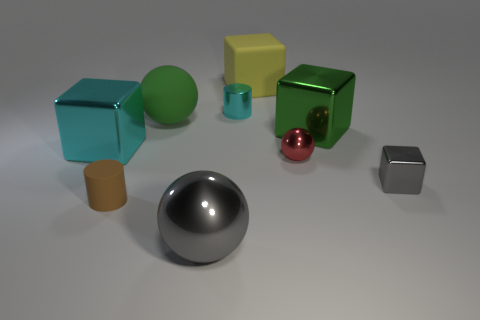What material is the big cyan thing that is the same shape as the tiny gray thing?
Ensure brevity in your answer.  Metal. There is a metal cube that is left of the large yellow object; is its color the same as the tiny metal cylinder?
Your answer should be very brief. Yes. What number of large yellow things are there?
Ensure brevity in your answer.  1. Is the gray thing left of the yellow matte thing made of the same material as the gray cube?
Your answer should be compact. Yes. There is a cyan object that is in front of the tiny metallic thing that is behind the red shiny object; how many shiny balls are behind it?
Keep it short and to the point. 0. How big is the brown object?
Offer a terse response. Small. Do the tiny metal block and the large metallic ball have the same color?
Give a very brief answer. Yes. What size is the cylinder that is in front of the small red ball?
Offer a very short reply. Small. Does the shiny sphere that is in front of the gray block have the same color as the cube that is in front of the cyan metallic cube?
Offer a very short reply. Yes. How many other things are the same shape as the small cyan thing?
Give a very brief answer. 1. 